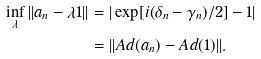<formula> <loc_0><loc_0><loc_500><loc_500>\inf _ { \lambda } | | a _ { n } - \lambda 1 | | & = | \exp [ i ( \delta _ { n } - \gamma _ { n } ) / 2 ] - 1 | \\ & = | | A d ( a _ { n } ) - A d ( 1 ) | | .</formula> 